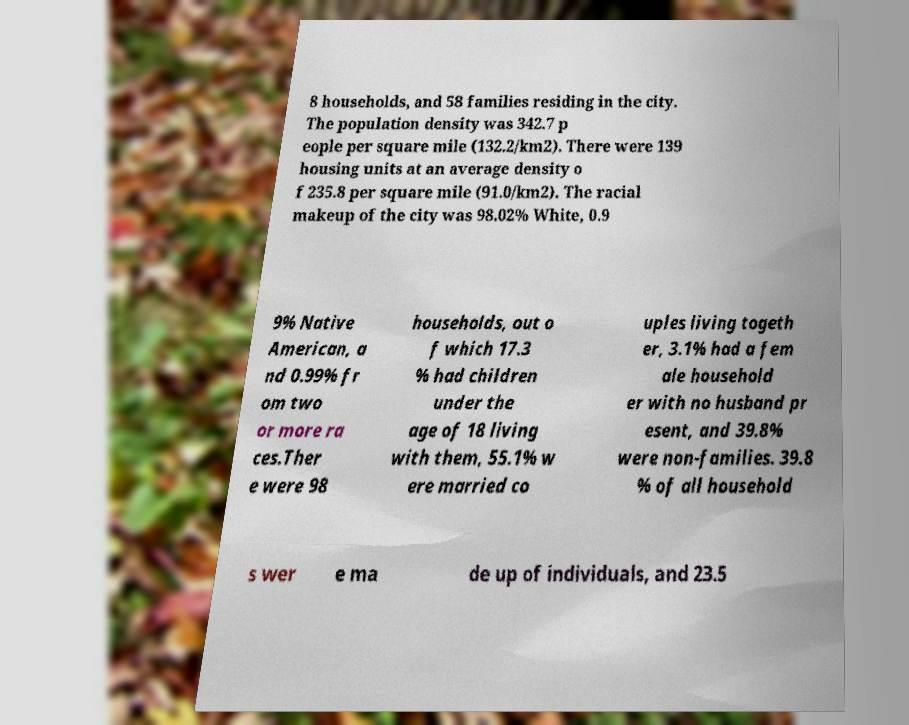Can you accurately transcribe the text from the provided image for me? 8 households, and 58 families residing in the city. The population density was 342.7 p eople per square mile (132.2/km2). There were 139 housing units at an average density o f 235.8 per square mile (91.0/km2). The racial makeup of the city was 98.02% White, 0.9 9% Native American, a nd 0.99% fr om two or more ra ces.Ther e were 98 households, out o f which 17.3 % had children under the age of 18 living with them, 55.1% w ere married co uples living togeth er, 3.1% had a fem ale household er with no husband pr esent, and 39.8% were non-families. 39.8 % of all household s wer e ma de up of individuals, and 23.5 